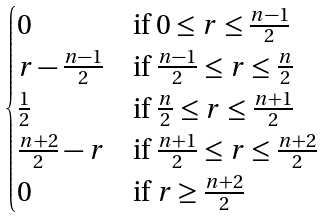Convert formula to latex. <formula><loc_0><loc_0><loc_500><loc_500>\begin{cases} 0 & \text {if $0\leq r \leq \frac{n-1}{2}$} \\ r - \frac { n - 1 } { 2 } & \text {if $\frac{n-1}{2}\leq r \leq   \frac{n}{2}$} \\ \frac { 1 } { 2 } & \text {if $\frac{n}{2}\leq r \leq \frac{n+1}{2}$} \\ \frac { n + 2 } { 2 } - r & \text {if $\frac{n+1}{2}\leq r\leq \frac{n+2}{2}$} \\ 0 & \text {if $r\geq \frac{n+2}{2}$} \\ \end{cases}</formula> 